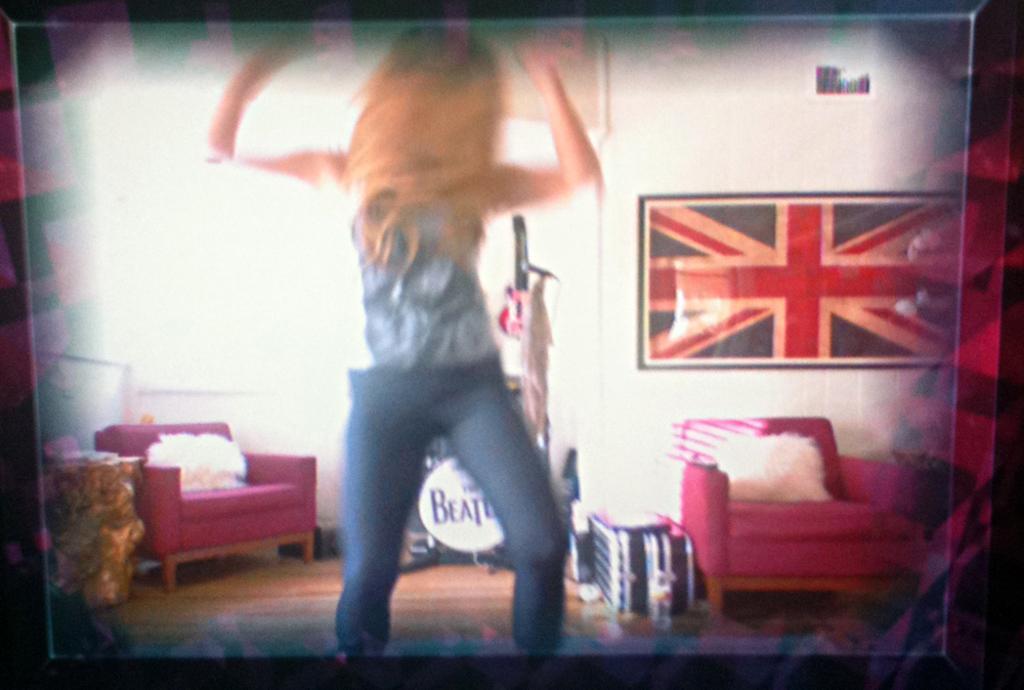Describe this image in one or two sentences. In the picture we can see a woman standing in blue and white top and blue jeans, in the background we can see a flag to the wall, a chair which is red in color, beside the chair there are two suite cases, and beside to it there is one more chair with the pillow. 